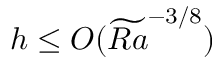<formula> <loc_0><loc_0><loc_500><loc_500>h \leq O ( \widetilde { R a } ^ { - 3 / 8 } )</formula> 